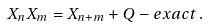<formula> <loc_0><loc_0><loc_500><loc_500>X _ { n } X _ { m } = X _ { n + m } + Q - e x a c t \, .</formula> 